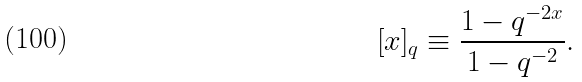<formula> <loc_0><loc_0><loc_500><loc_500>[ x ] _ { q } \equiv \frac { 1 - q ^ { - 2 x } } { 1 - q ^ { - 2 } } .</formula> 